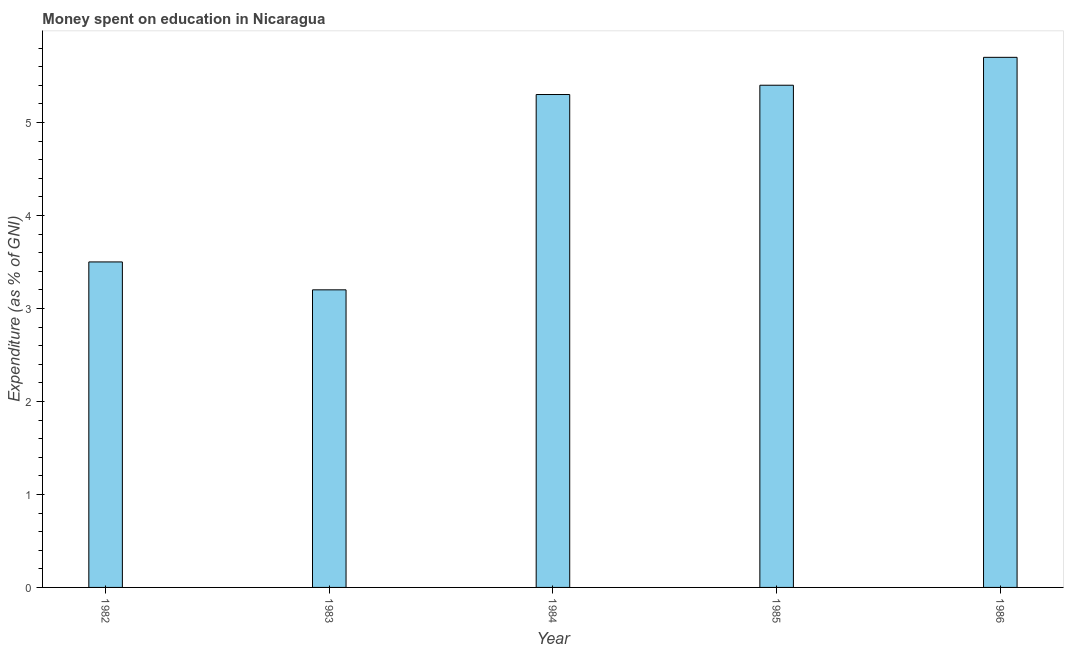Does the graph contain grids?
Ensure brevity in your answer.  No. What is the title of the graph?
Your response must be concise. Money spent on education in Nicaragua. What is the label or title of the Y-axis?
Offer a very short reply. Expenditure (as % of GNI). Across all years, what is the minimum expenditure on education?
Give a very brief answer. 3.2. In which year was the expenditure on education maximum?
Provide a short and direct response. 1986. What is the sum of the expenditure on education?
Offer a terse response. 23.1. What is the average expenditure on education per year?
Make the answer very short. 4.62. What is the median expenditure on education?
Your answer should be compact. 5.3. What is the ratio of the expenditure on education in 1982 to that in 1983?
Offer a very short reply. 1.09. What is the difference between the highest and the second highest expenditure on education?
Offer a terse response. 0.3. In how many years, is the expenditure on education greater than the average expenditure on education taken over all years?
Your answer should be compact. 3. Are all the bars in the graph horizontal?
Ensure brevity in your answer.  No. How many years are there in the graph?
Provide a succinct answer. 5. What is the difference between two consecutive major ticks on the Y-axis?
Give a very brief answer. 1. Are the values on the major ticks of Y-axis written in scientific E-notation?
Give a very brief answer. No. What is the Expenditure (as % of GNI) in 1983?
Your answer should be compact. 3.2. What is the Expenditure (as % of GNI) in 1984?
Provide a succinct answer. 5.3. What is the Expenditure (as % of GNI) in 1985?
Your answer should be compact. 5.4. What is the Expenditure (as % of GNI) in 1986?
Give a very brief answer. 5.7. What is the difference between the Expenditure (as % of GNI) in 1982 and 1986?
Your answer should be very brief. -2.2. What is the difference between the Expenditure (as % of GNI) in 1983 and 1984?
Make the answer very short. -2.1. What is the difference between the Expenditure (as % of GNI) in 1985 and 1986?
Keep it short and to the point. -0.3. What is the ratio of the Expenditure (as % of GNI) in 1982 to that in 1983?
Your response must be concise. 1.09. What is the ratio of the Expenditure (as % of GNI) in 1982 to that in 1984?
Offer a very short reply. 0.66. What is the ratio of the Expenditure (as % of GNI) in 1982 to that in 1985?
Provide a succinct answer. 0.65. What is the ratio of the Expenditure (as % of GNI) in 1982 to that in 1986?
Make the answer very short. 0.61. What is the ratio of the Expenditure (as % of GNI) in 1983 to that in 1984?
Ensure brevity in your answer.  0.6. What is the ratio of the Expenditure (as % of GNI) in 1983 to that in 1985?
Your answer should be very brief. 0.59. What is the ratio of the Expenditure (as % of GNI) in 1983 to that in 1986?
Provide a short and direct response. 0.56. What is the ratio of the Expenditure (as % of GNI) in 1985 to that in 1986?
Offer a very short reply. 0.95. 